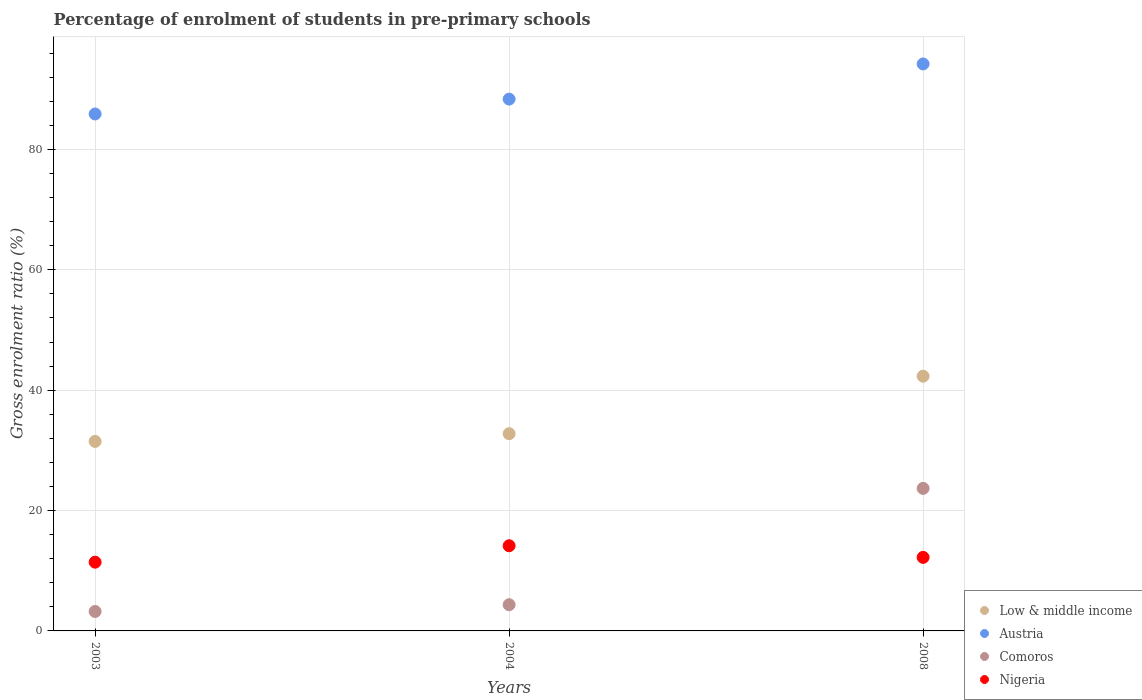How many different coloured dotlines are there?
Give a very brief answer. 4. Is the number of dotlines equal to the number of legend labels?
Provide a short and direct response. Yes. What is the percentage of students enrolled in pre-primary schools in Austria in 2008?
Your answer should be compact. 94.21. Across all years, what is the maximum percentage of students enrolled in pre-primary schools in Austria?
Offer a very short reply. 94.21. Across all years, what is the minimum percentage of students enrolled in pre-primary schools in Comoros?
Provide a succinct answer. 3.23. What is the total percentage of students enrolled in pre-primary schools in Nigeria in the graph?
Offer a very short reply. 37.8. What is the difference between the percentage of students enrolled in pre-primary schools in Low & middle income in 2004 and that in 2008?
Offer a terse response. -9.55. What is the difference between the percentage of students enrolled in pre-primary schools in Comoros in 2003 and the percentage of students enrolled in pre-primary schools in Low & middle income in 2008?
Your response must be concise. -39.09. What is the average percentage of students enrolled in pre-primary schools in Low & middle income per year?
Ensure brevity in your answer.  35.53. In the year 2008, what is the difference between the percentage of students enrolled in pre-primary schools in Austria and percentage of students enrolled in pre-primary schools in Nigeria?
Provide a short and direct response. 81.99. In how many years, is the percentage of students enrolled in pre-primary schools in Low & middle income greater than 28 %?
Provide a short and direct response. 3. What is the ratio of the percentage of students enrolled in pre-primary schools in Nigeria in 2004 to that in 2008?
Offer a terse response. 1.16. Is the percentage of students enrolled in pre-primary schools in Comoros in 2003 less than that in 2004?
Give a very brief answer. Yes. What is the difference between the highest and the second highest percentage of students enrolled in pre-primary schools in Austria?
Offer a very short reply. 5.84. What is the difference between the highest and the lowest percentage of students enrolled in pre-primary schools in Low & middle income?
Provide a short and direct response. 10.83. In how many years, is the percentage of students enrolled in pre-primary schools in Austria greater than the average percentage of students enrolled in pre-primary schools in Austria taken over all years?
Offer a very short reply. 1. Is it the case that in every year, the sum of the percentage of students enrolled in pre-primary schools in Comoros and percentage of students enrolled in pre-primary schools in Low & middle income  is greater than the sum of percentage of students enrolled in pre-primary schools in Austria and percentage of students enrolled in pre-primary schools in Nigeria?
Provide a succinct answer. Yes. How many years are there in the graph?
Provide a short and direct response. 3. What is the difference between two consecutive major ticks on the Y-axis?
Provide a succinct answer. 20. Does the graph contain grids?
Your response must be concise. Yes. Where does the legend appear in the graph?
Provide a succinct answer. Bottom right. How are the legend labels stacked?
Your answer should be very brief. Vertical. What is the title of the graph?
Ensure brevity in your answer.  Percentage of enrolment of students in pre-primary schools. Does "Brazil" appear as one of the legend labels in the graph?
Provide a succinct answer. No. What is the label or title of the X-axis?
Keep it short and to the point. Years. What is the label or title of the Y-axis?
Give a very brief answer. Gross enrolment ratio (%). What is the Gross enrolment ratio (%) in Low & middle income in 2003?
Ensure brevity in your answer.  31.49. What is the Gross enrolment ratio (%) of Austria in 2003?
Your answer should be compact. 85.9. What is the Gross enrolment ratio (%) of Comoros in 2003?
Make the answer very short. 3.23. What is the Gross enrolment ratio (%) in Nigeria in 2003?
Provide a short and direct response. 11.42. What is the Gross enrolment ratio (%) in Low & middle income in 2004?
Your answer should be compact. 32.77. What is the Gross enrolment ratio (%) of Austria in 2004?
Make the answer very short. 88.37. What is the Gross enrolment ratio (%) of Comoros in 2004?
Provide a succinct answer. 4.36. What is the Gross enrolment ratio (%) of Nigeria in 2004?
Provide a short and direct response. 14.15. What is the Gross enrolment ratio (%) of Low & middle income in 2008?
Your response must be concise. 42.33. What is the Gross enrolment ratio (%) of Austria in 2008?
Offer a terse response. 94.21. What is the Gross enrolment ratio (%) of Comoros in 2008?
Give a very brief answer. 23.69. What is the Gross enrolment ratio (%) of Nigeria in 2008?
Your answer should be very brief. 12.22. Across all years, what is the maximum Gross enrolment ratio (%) of Low & middle income?
Your response must be concise. 42.33. Across all years, what is the maximum Gross enrolment ratio (%) of Austria?
Give a very brief answer. 94.21. Across all years, what is the maximum Gross enrolment ratio (%) of Comoros?
Your answer should be compact. 23.69. Across all years, what is the maximum Gross enrolment ratio (%) in Nigeria?
Your answer should be very brief. 14.15. Across all years, what is the minimum Gross enrolment ratio (%) of Low & middle income?
Give a very brief answer. 31.49. Across all years, what is the minimum Gross enrolment ratio (%) of Austria?
Your answer should be very brief. 85.9. Across all years, what is the minimum Gross enrolment ratio (%) of Comoros?
Offer a very short reply. 3.23. Across all years, what is the minimum Gross enrolment ratio (%) of Nigeria?
Offer a very short reply. 11.42. What is the total Gross enrolment ratio (%) in Low & middle income in the graph?
Keep it short and to the point. 106.59. What is the total Gross enrolment ratio (%) in Austria in the graph?
Your response must be concise. 268.48. What is the total Gross enrolment ratio (%) of Comoros in the graph?
Your response must be concise. 31.27. What is the total Gross enrolment ratio (%) in Nigeria in the graph?
Provide a short and direct response. 37.8. What is the difference between the Gross enrolment ratio (%) of Low & middle income in 2003 and that in 2004?
Keep it short and to the point. -1.28. What is the difference between the Gross enrolment ratio (%) of Austria in 2003 and that in 2004?
Make the answer very short. -2.47. What is the difference between the Gross enrolment ratio (%) of Comoros in 2003 and that in 2004?
Provide a succinct answer. -1.12. What is the difference between the Gross enrolment ratio (%) in Nigeria in 2003 and that in 2004?
Your response must be concise. -2.73. What is the difference between the Gross enrolment ratio (%) of Low & middle income in 2003 and that in 2008?
Keep it short and to the point. -10.83. What is the difference between the Gross enrolment ratio (%) of Austria in 2003 and that in 2008?
Provide a succinct answer. -8.31. What is the difference between the Gross enrolment ratio (%) of Comoros in 2003 and that in 2008?
Keep it short and to the point. -20.45. What is the difference between the Gross enrolment ratio (%) of Nigeria in 2003 and that in 2008?
Your response must be concise. -0.8. What is the difference between the Gross enrolment ratio (%) in Low & middle income in 2004 and that in 2008?
Keep it short and to the point. -9.55. What is the difference between the Gross enrolment ratio (%) of Austria in 2004 and that in 2008?
Offer a very short reply. -5.84. What is the difference between the Gross enrolment ratio (%) in Comoros in 2004 and that in 2008?
Your answer should be compact. -19.33. What is the difference between the Gross enrolment ratio (%) of Nigeria in 2004 and that in 2008?
Give a very brief answer. 1.93. What is the difference between the Gross enrolment ratio (%) of Low & middle income in 2003 and the Gross enrolment ratio (%) of Austria in 2004?
Provide a short and direct response. -56.88. What is the difference between the Gross enrolment ratio (%) of Low & middle income in 2003 and the Gross enrolment ratio (%) of Comoros in 2004?
Keep it short and to the point. 27.14. What is the difference between the Gross enrolment ratio (%) of Low & middle income in 2003 and the Gross enrolment ratio (%) of Nigeria in 2004?
Give a very brief answer. 17.34. What is the difference between the Gross enrolment ratio (%) in Austria in 2003 and the Gross enrolment ratio (%) in Comoros in 2004?
Provide a short and direct response. 81.54. What is the difference between the Gross enrolment ratio (%) of Austria in 2003 and the Gross enrolment ratio (%) of Nigeria in 2004?
Ensure brevity in your answer.  71.75. What is the difference between the Gross enrolment ratio (%) of Comoros in 2003 and the Gross enrolment ratio (%) of Nigeria in 2004?
Your response must be concise. -10.92. What is the difference between the Gross enrolment ratio (%) of Low & middle income in 2003 and the Gross enrolment ratio (%) of Austria in 2008?
Keep it short and to the point. -62.72. What is the difference between the Gross enrolment ratio (%) of Low & middle income in 2003 and the Gross enrolment ratio (%) of Comoros in 2008?
Offer a terse response. 7.81. What is the difference between the Gross enrolment ratio (%) in Low & middle income in 2003 and the Gross enrolment ratio (%) in Nigeria in 2008?
Provide a succinct answer. 19.27. What is the difference between the Gross enrolment ratio (%) in Austria in 2003 and the Gross enrolment ratio (%) in Comoros in 2008?
Your response must be concise. 62.21. What is the difference between the Gross enrolment ratio (%) of Austria in 2003 and the Gross enrolment ratio (%) of Nigeria in 2008?
Your answer should be compact. 73.68. What is the difference between the Gross enrolment ratio (%) in Comoros in 2003 and the Gross enrolment ratio (%) in Nigeria in 2008?
Ensure brevity in your answer.  -8.99. What is the difference between the Gross enrolment ratio (%) of Low & middle income in 2004 and the Gross enrolment ratio (%) of Austria in 2008?
Give a very brief answer. -61.44. What is the difference between the Gross enrolment ratio (%) in Low & middle income in 2004 and the Gross enrolment ratio (%) in Comoros in 2008?
Your answer should be compact. 9.09. What is the difference between the Gross enrolment ratio (%) in Low & middle income in 2004 and the Gross enrolment ratio (%) in Nigeria in 2008?
Offer a terse response. 20.55. What is the difference between the Gross enrolment ratio (%) of Austria in 2004 and the Gross enrolment ratio (%) of Comoros in 2008?
Provide a succinct answer. 64.68. What is the difference between the Gross enrolment ratio (%) in Austria in 2004 and the Gross enrolment ratio (%) in Nigeria in 2008?
Provide a short and direct response. 76.15. What is the difference between the Gross enrolment ratio (%) in Comoros in 2004 and the Gross enrolment ratio (%) in Nigeria in 2008?
Offer a terse response. -7.87. What is the average Gross enrolment ratio (%) of Low & middle income per year?
Provide a succinct answer. 35.53. What is the average Gross enrolment ratio (%) in Austria per year?
Your answer should be compact. 89.49. What is the average Gross enrolment ratio (%) of Comoros per year?
Make the answer very short. 10.42. What is the average Gross enrolment ratio (%) in Nigeria per year?
Make the answer very short. 12.6. In the year 2003, what is the difference between the Gross enrolment ratio (%) in Low & middle income and Gross enrolment ratio (%) in Austria?
Offer a terse response. -54.41. In the year 2003, what is the difference between the Gross enrolment ratio (%) of Low & middle income and Gross enrolment ratio (%) of Comoros?
Offer a very short reply. 28.26. In the year 2003, what is the difference between the Gross enrolment ratio (%) of Low & middle income and Gross enrolment ratio (%) of Nigeria?
Provide a short and direct response. 20.07. In the year 2003, what is the difference between the Gross enrolment ratio (%) in Austria and Gross enrolment ratio (%) in Comoros?
Keep it short and to the point. 82.67. In the year 2003, what is the difference between the Gross enrolment ratio (%) in Austria and Gross enrolment ratio (%) in Nigeria?
Keep it short and to the point. 74.48. In the year 2003, what is the difference between the Gross enrolment ratio (%) in Comoros and Gross enrolment ratio (%) in Nigeria?
Keep it short and to the point. -8.19. In the year 2004, what is the difference between the Gross enrolment ratio (%) of Low & middle income and Gross enrolment ratio (%) of Austria?
Make the answer very short. -55.6. In the year 2004, what is the difference between the Gross enrolment ratio (%) of Low & middle income and Gross enrolment ratio (%) of Comoros?
Make the answer very short. 28.42. In the year 2004, what is the difference between the Gross enrolment ratio (%) of Low & middle income and Gross enrolment ratio (%) of Nigeria?
Offer a terse response. 18.62. In the year 2004, what is the difference between the Gross enrolment ratio (%) in Austria and Gross enrolment ratio (%) in Comoros?
Ensure brevity in your answer.  84.01. In the year 2004, what is the difference between the Gross enrolment ratio (%) of Austria and Gross enrolment ratio (%) of Nigeria?
Offer a very short reply. 74.22. In the year 2004, what is the difference between the Gross enrolment ratio (%) of Comoros and Gross enrolment ratio (%) of Nigeria?
Your response must be concise. -9.8. In the year 2008, what is the difference between the Gross enrolment ratio (%) of Low & middle income and Gross enrolment ratio (%) of Austria?
Offer a terse response. -51.89. In the year 2008, what is the difference between the Gross enrolment ratio (%) in Low & middle income and Gross enrolment ratio (%) in Comoros?
Provide a succinct answer. 18.64. In the year 2008, what is the difference between the Gross enrolment ratio (%) in Low & middle income and Gross enrolment ratio (%) in Nigeria?
Your answer should be compact. 30.11. In the year 2008, what is the difference between the Gross enrolment ratio (%) of Austria and Gross enrolment ratio (%) of Comoros?
Your response must be concise. 70.53. In the year 2008, what is the difference between the Gross enrolment ratio (%) in Austria and Gross enrolment ratio (%) in Nigeria?
Provide a succinct answer. 81.99. In the year 2008, what is the difference between the Gross enrolment ratio (%) in Comoros and Gross enrolment ratio (%) in Nigeria?
Provide a succinct answer. 11.46. What is the ratio of the Gross enrolment ratio (%) in Low & middle income in 2003 to that in 2004?
Offer a terse response. 0.96. What is the ratio of the Gross enrolment ratio (%) of Austria in 2003 to that in 2004?
Provide a succinct answer. 0.97. What is the ratio of the Gross enrolment ratio (%) in Comoros in 2003 to that in 2004?
Provide a short and direct response. 0.74. What is the ratio of the Gross enrolment ratio (%) of Nigeria in 2003 to that in 2004?
Make the answer very short. 0.81. What is the ratio of the Gross enrolment ratio (%) in Low & middle income in 2003 to that in 2008?
Your response must be concise. 0.74. What is the ratio of the Gross enrolment ratio (%) in Austria in 2003 to that in 2008?
Your answer should be very brief. 0.91. What is the ratio of the Gross enrolment ratio (%) in Comoros in 2003 to that in 2008?
Your answer should be compact. 0.14. What is the ratio of the Gross enrolment ratio (%) of Nigeria in 2003 to that in 2008?
Your answer should be compact. 0.93. What is the ratio of the Gross enrolment ratio (%) of Low & middle income in 2004 to that in 2008?
Give a very brief answer. 0.77. What is the ratio of the Gross enrolment ratio (%) of Austria in 2004 to that in 2008?
Your response must be concise. 0.94. What is the ratio of the Gross enrolment ratio (%) in Comoros in 2004 to that in 2008?
Offer a terse response. 0.18. What is the ratio of the Gross enrolment ratio (%) of Nigeria in 2004 to that in 2008?
Your response must be concise. 1.16. What is the difference between the highest and the second highest Gross enrolment ratio (%) in Low & middle income?
Keep it short and to the point. 9.55. What is the difference between the highest and the second highest Gross enrolment ratio (%) of Austria?
Keep it short and to the point. 5.84. What is the difference between the highest and the second highest Gross enrolment ratio (%) in Comoros?
Provide a short and direct response. 19.33. What is the difference between the highest and the second highest Gross enrolment ratio (%) of Nigeria?
Your answer should be compact. 1.93. What is the difference between the highest and the lowest Gross enrolment ratio (%) of Low & middle income?
Keep it short and to the point. 10.83. What is the difference between the highest and the lowest Gross enrolment ratio (%) of Austria?
Give a very brief answer. 8.31. What is the difference between the highest and the lowest Gross enrolment ratio (%) of Comoros?
Your answer should be very brief. 20.45. What is the difference between the highest and the lowest Gross enrolment ratio (%) of Nigeria?
Give a very brief answer. 2.73. 